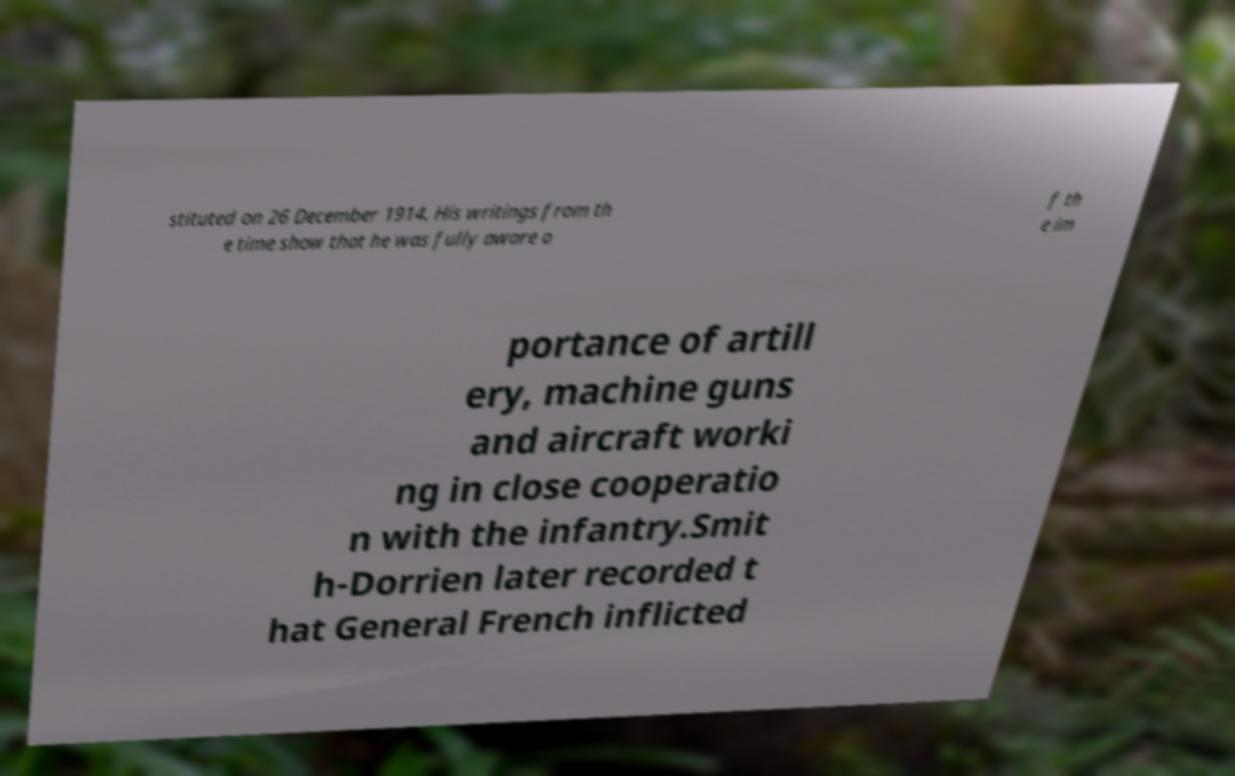What messages or text are displayed in this image? I need them in a readable, typed format. stituted on 26 December 1914. His writings from th e time show that he was fully aware o f th e im portance of artill ery, machine guns and aircraft worki ng in close cooperatio n with the infantry.Smit h-Dorrien later recorded t hat General French inflicted 